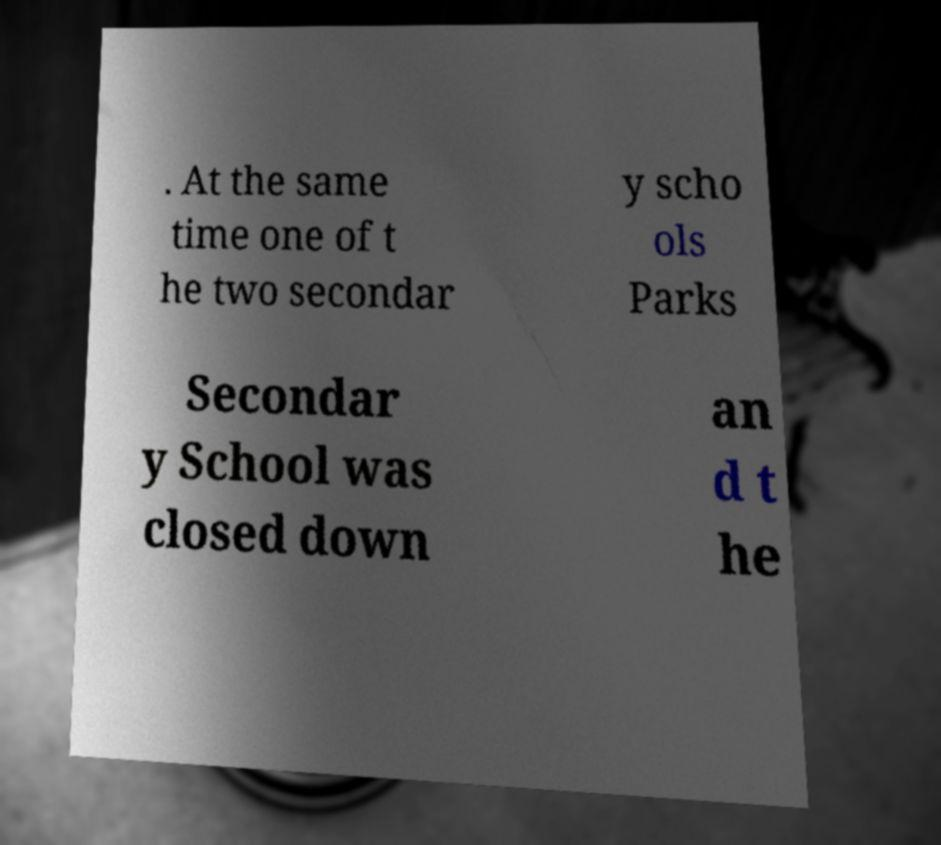What messages or text are displayed in this image? I need them in a readable, typed format. . At the same time one of t he two secondar y scho ols Parks Secondar y School was closed down an d t he 